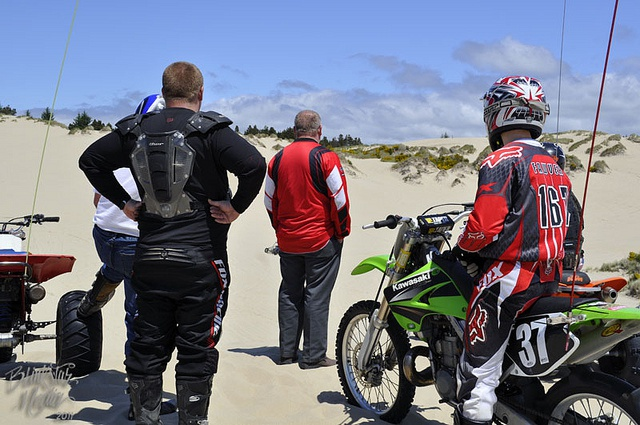Describe the objects in this image and their specific colors. I can see motorcycle in lightblue, black, gray, darkgray, and lightgray tones, people in darkgray, black, gray, and lavender tones, people in lightblue, black, gray, lavender, and maroon tones, people in lightblue, black, maroon, brown, and gray tones, and motorcycle in lightblue, black, lightgray, maroon, and gray tones in this image. 